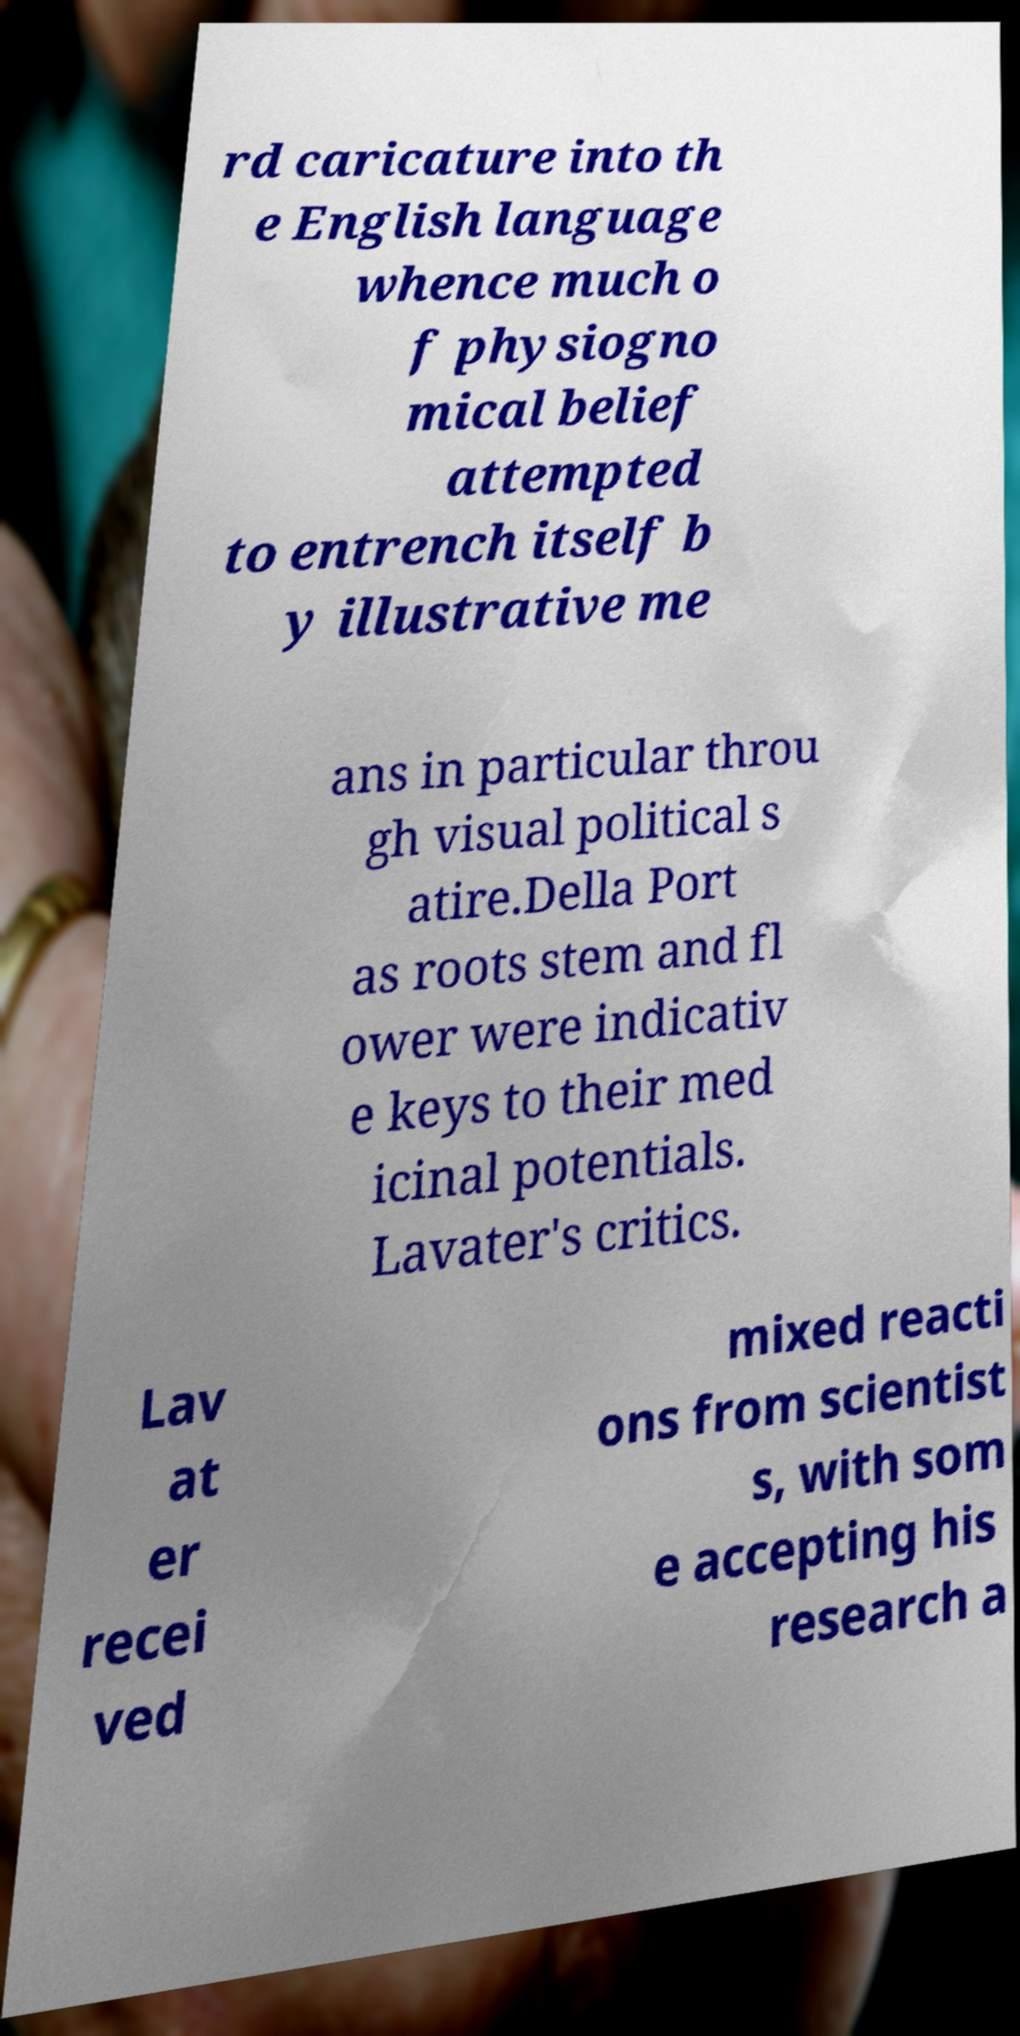Can you accurately transcribe the text from the provided image for me? rd caricature into th e English language whence much o f physiogno mical belief attempted to entrench itself b y illustrative me ans in particular throu gh visual political s atire.Della Port as roots stem and fl ower were indicativ e keys to their med icinal potentials. Lavater's critics. Lav at er recei ved mixed reacti ons from scientist s, with som e accepting his research a 